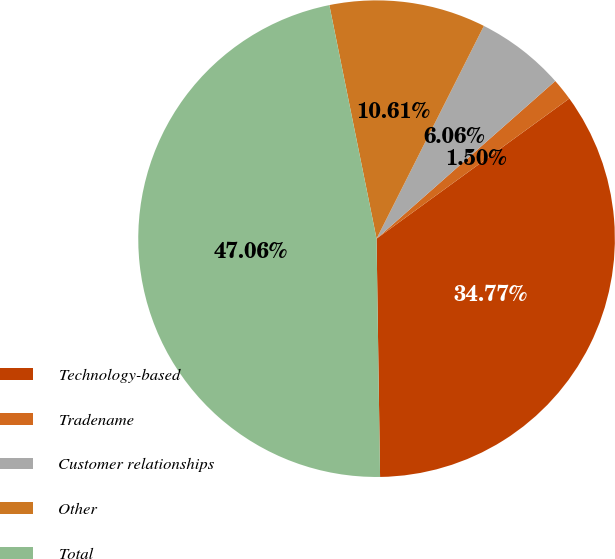Convert chart. <chart><loc_0><loc_0><loc_500><loc_500><pie_chart><fcel>Technology-based<fcel>Tradename<fcel>Customer relationships<fcel>Other<fcel>Total<nl><fcel>34.77%<fcel>1.5%<fcel>6.06%<fcel>10.61%<fcel>47.06%<nl></chart> 